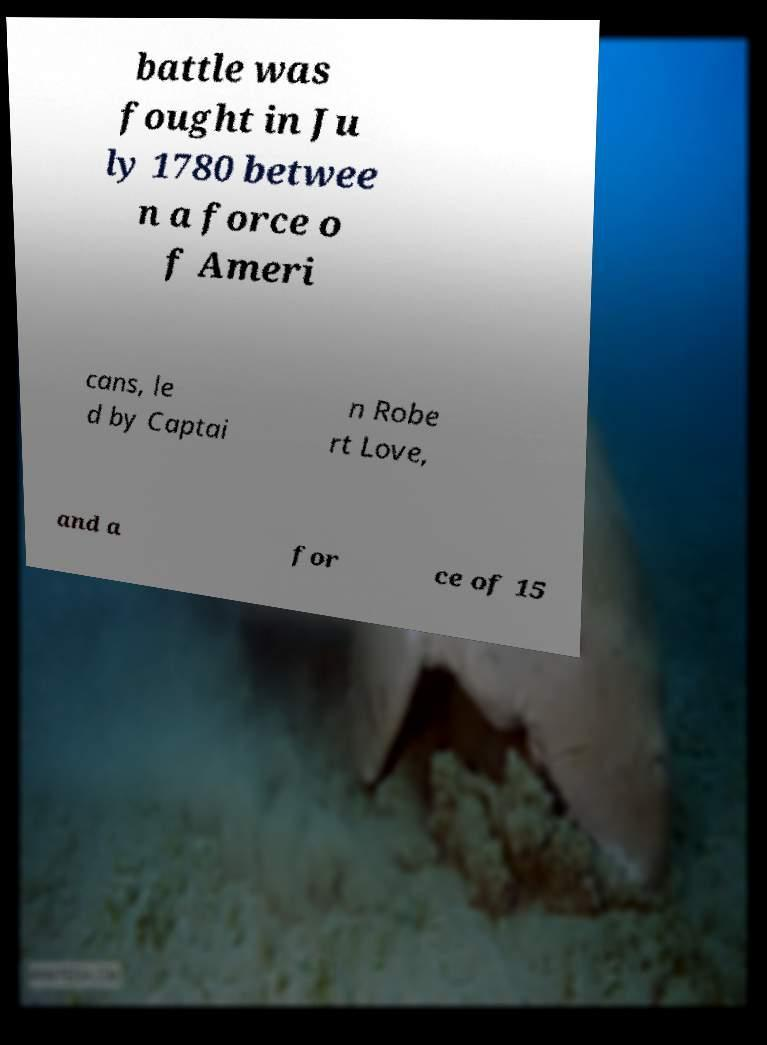Could you assist in decoding the text presented in this image and type it out clearly? battle was fought in Ju ly 1780 betwee n a force o f Ameri cans, le d by Captai n Robe rt Love, and a for ce of 15 